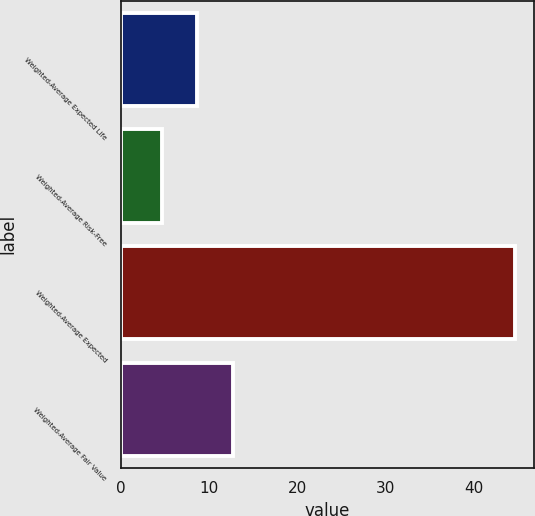<chart> <loc_0><loc_0><loc_500><loc_500><bar_chart><fcel>Weighted-Average Expected Life<fcel>Weighted-Average Risk-Free<fcel>Weighted-Average Expected<fcel>Weighted-Average Fair Value<nl><fcel>8.69<fcel>4.7<fcel>44.6<fcel>12.68<nl></chart> 